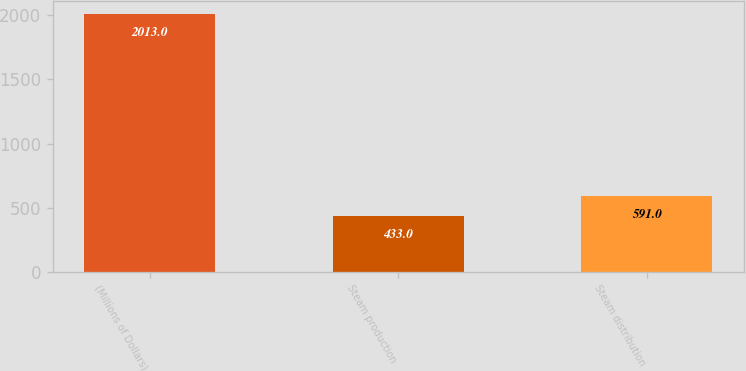Convert chart. <chart><loc_0><loc_0><loc_500><loc_500><bar_chart><fcel>(Millions of Dollars)<fcel>Steam production<fcel>Steam distribution<nl><fcel>2013<fcel>433<fcel>591<nl></chart> 